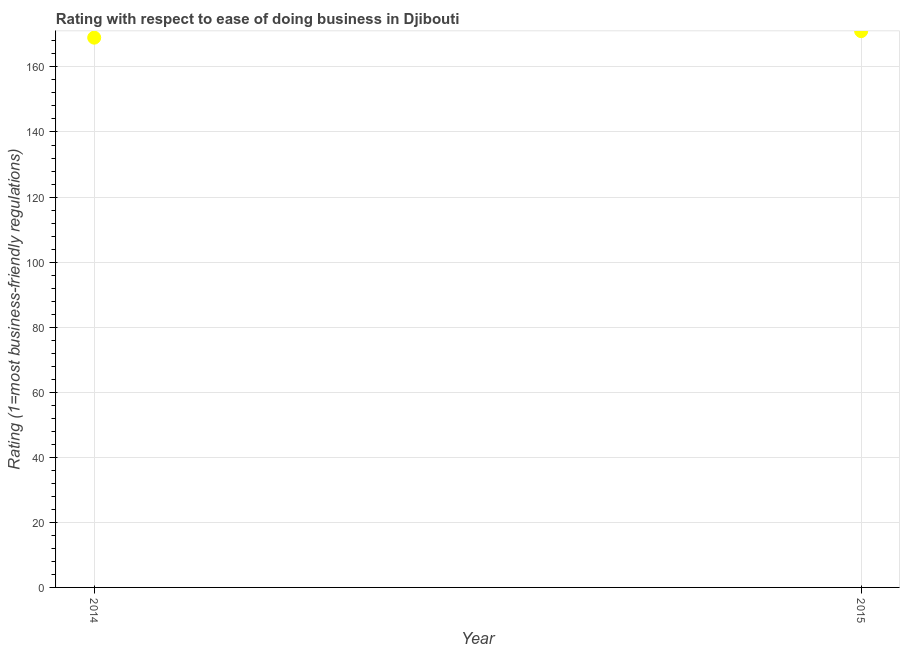What is the ease of doing business index in 2014?
Make the answer very short. 169. Across all years, what is the maximum ease of doing business index?
Your answer should be very brief. 171. Across all years, what is the minimum ease of doing business index?
Provide a succinct answer. 169. In which year was the ease of doing business index maximum?
Ensure brevity in your answer.  2015. In which year was the ease of doing business index minimum?
Offer a terse response. 2014. What is the sum of the ease of doing business index?
Your answer should be very brief. 340. What is the difference between the ease of doing business index in 2014 and 2015?
Your answer should be compact. -2. What is the average ease of doing business index per year?
Provide a short and direct response. 170. What is the median ease of doing business index?
Keep it short and to the point. 170. In how many years, is the ease of doing business index greater than 8 ?
Your answer should be very brief. 2. What is the ratio of the ease of doing business index in 2014 to that in 2015?
Your answer should be very brief. 0.99. Does the ease of doing business index monotonically increase over the years?
Keep it short and to the point. Yes. How many years are there in the graph?
Make the answer very short. 2. Does the graph contain any zero values?
Offer a very short reply. No. Does the graph contain grids?
Keep it short and to the point. Yes. What is the title of the graph?
Make the answer very short. Rating with respect to ease of doing business in Djibouti. What is the label or title of the Y-axis?
Keep it short and to the point. Rating (1=most business-friendly regulations). What is the Rating (1=most business-friendly regulations) in 2014?
Make the answer very short. 169. What is the Rating (1=most business-friendly regulations) in 2015?
Ensure brevity in your answer.  171. What is the difference between the Rating (1=most business-friendly regulations) in 2014 and 2015?
Ensure brevity in your answer.  -2. What is the ratio of the Rating (1=most business-friendly regulations) in 2014 to that in 2015?
Offer a very short reply. 0.99. 